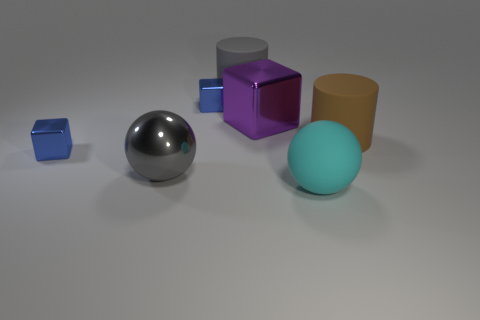There is a ball left of the large cyan thing; what is its material?
Your response must be concise. Metal. What is the color of the big ball that is the same material as the purple block?
Keep it short and to the point. Gray. How many gray rubber cylinders have the same size as the purple block?
Ensure brevity in your answer.  1. There is a gray object that is in front of the gray rubber object; does it have the same size as the large gray cylinder?
Provide a succinct answer. Yes. What shape is the big object that is both in front of the big brown rubber object and to the right of the large gray metal sphere?
Your answer should be very brief. Sphere. Are there any cyan rubber balls behind the purple shiny object?
Offer a terse response. No. Are there any other things that have the same shape as the gray matte thing?
Provide a short and direct response. Yes. Is the big gray matte thing the same shape as the big cyan matte thing?
Offer a very short reply. No. Is the number of objects on the left side of the large purple block the same as the number of balls that are on the left side of the gray rubber cylinder?
Your response must be concise. No. How many other things are there of the same material as the large cyan sphere?
Make the answer very short. 2. 